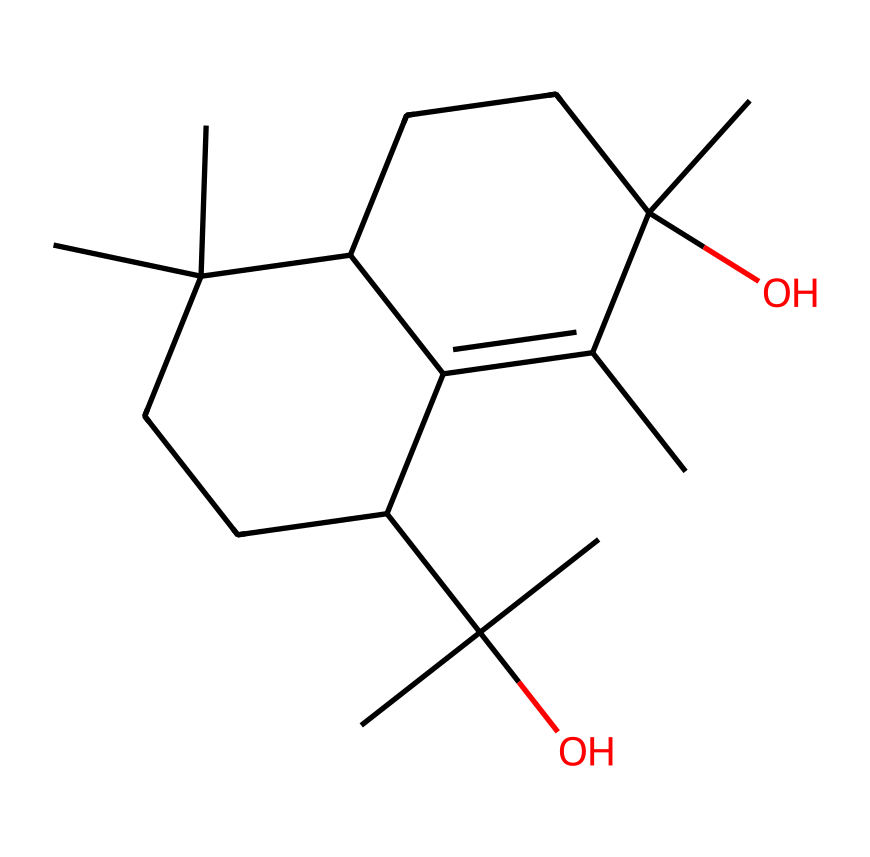What is the molecular formula of this compound? To derive the molecular formula, we count the types and number of each atom present in the structure represented by the SMILES. In this case, we identify 15 carbon atoms, 28 hydrogen atoms, and 2 oxygen atoms, leading to the molecular formula C15H28O2.
Answer: C15H28O2 How many oxygen atoms are present in this molecule? Looking at the SMILES representation, we can see that there are two oxygen atoms in the structure.
Answer: 2 What type of functional groups can be identified in this compound? The molecule exhibits ether functional groups characterized by the presence of oxygen atoms connected to carbons. Ethers are defined by the R-O-R structure, where ‘R’ represents an alkyl or aryl group. In this instance, the structure confirms the presence of ethers.
Answer: ether What is the total number of rings present in this structure? Upon examining the SMILES, we notice the notation indicating that there are two cyclic components, indicating the presence of two rings within the molecular structure.
Answer: 2 Is this molecule hydrophilic or hydrophobic? Given the presence of multiple carbon chains and two ether functional groups, the hydrophobic character dominates because of the long hydrocarbon tails, making the molecule largely insoluble in water.
Answer: hydrophobic How many chiral centers are present in this compound? By analyzing the structure for carbon atoms that are bonded to four different groups, we can pinpoint two chiral centers in this molecule, indicating its potential for stereoisomerism.
Answer: 2 What characteristic smell is associated with this compound? The compound represents oud, which is known for its rich, complex, and woody fragrance commonly attributed to its aromatic properties derived from the chemical composition.
Answer: woody 